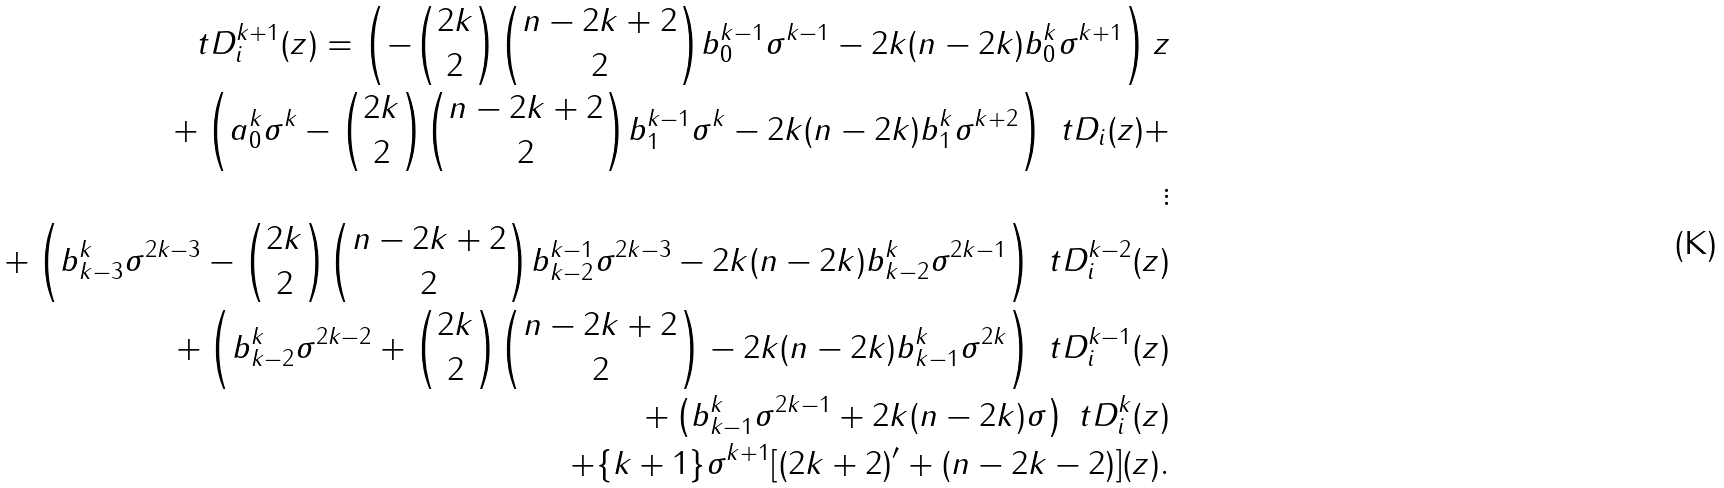<formula> <loc_0><loc_0><loc_500><loc_500>\ t D _ { i } ^ { k + 1 } ( z ) = \left ( - { 2 k \choose 2 } { n - 2 k + 2 \choose 2 } b _ { 0 } ^ { k - 1 } \sigma ^ { k - 1 } - 2 k ( n - 2 k ) b _ { 0 } ^ { k } \sigma ^ { k + 1 } \right ) z \\ + \left ( a _ { 0 } ^ { k } \sigma ^ { k } - { 2 k \choose 2 } { n - 2 k + 2 \choose 2 } b _ { 1 } ^ { k - 1 } \sigma ^ { k } - 2 k ( n - 2 k ) b _ { 1 } ^ { k } \sigma ^ { k + 2 } \right ) \ t D _ { i } ( z ) + \\ \vdots \\ + \left ( b _ { k - 3 } ^ { k } \sigma ^ { 2 k - 3 } - { 2 k \choose 2 } { n - 2 k + 2 \choose 2 } b _ { k - 2 } ^ { k - 1 } \sigma ^ { 2 k - 3 } - 2 k ( n - 2 k ) b _ { k - 2 } ^ { k } \sigma ^ { 2 k - 1 } \right ) \ t D _ { i } ^ { k - 2 } ( z ) \\ + \left ( b _ { k - 2 } ^ { k } \sigma ^ { 2 k - 2 } + { 2 k \choose 2 } { n - 2 k + 2 \choose 2 } - 2 k ( n - 2 k ) b _ { k - 1 } ^ { k } \sigma ^ { 2 k } \right ) \ t D _ { i } ^ { k - 1 } ( z ) \\ + \left ( b _ { k - 1 } ^ { k } \sigma ^ { 2 k - 1 } + 2 k ( n - 2 k ) \sigma \right ) \ t D _ { i } ^ { k } ( z ) \\ + \{ k + 1 \} \sigma ^ { k + 1 } [ ( 2 k + 2 ) ^ { \prime } + ( n - 2 k - 2 ) ] ( z ) .</formula> 